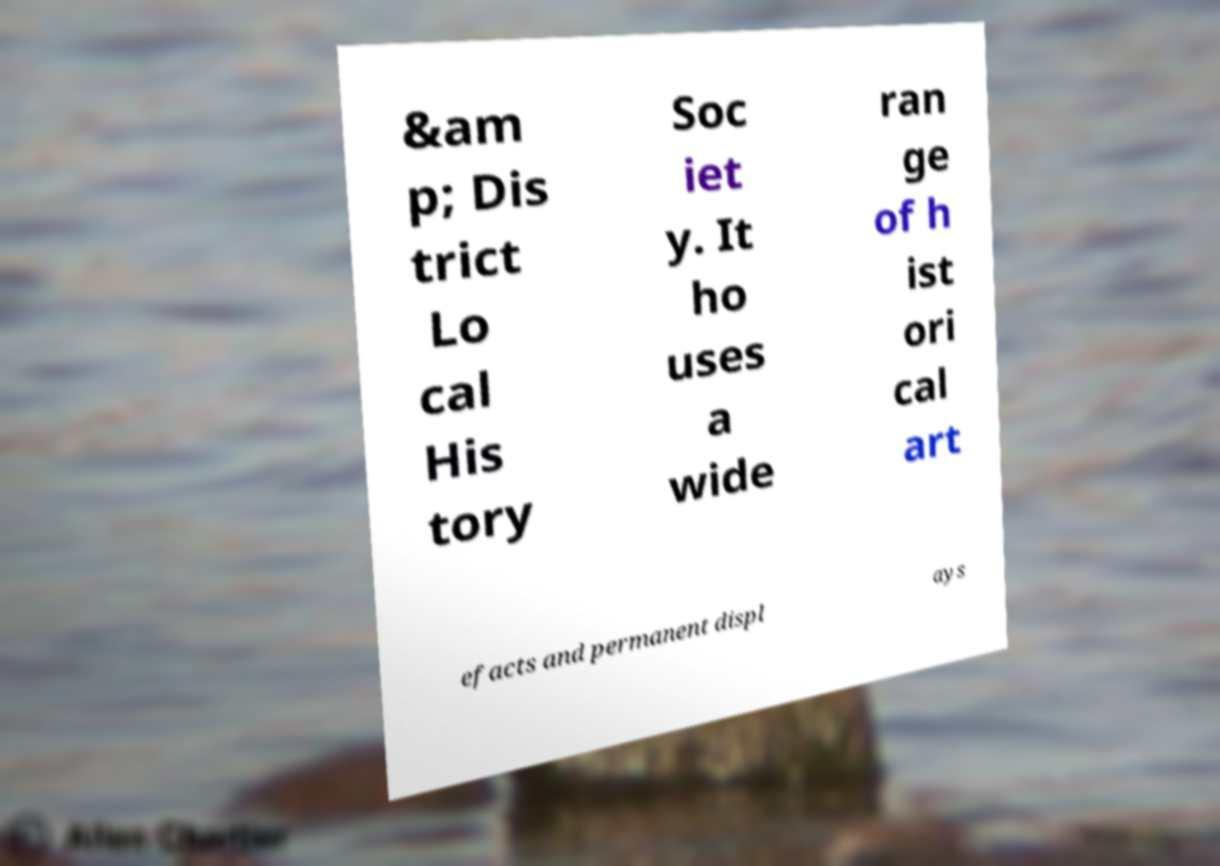Can you accurately transcribe the text from the provided image for me? &am p; Dis trict Lo cal His tory Soc iet y. It ho uses a wide ran ge of h ist ori cal art efacts and permanent displ ays 